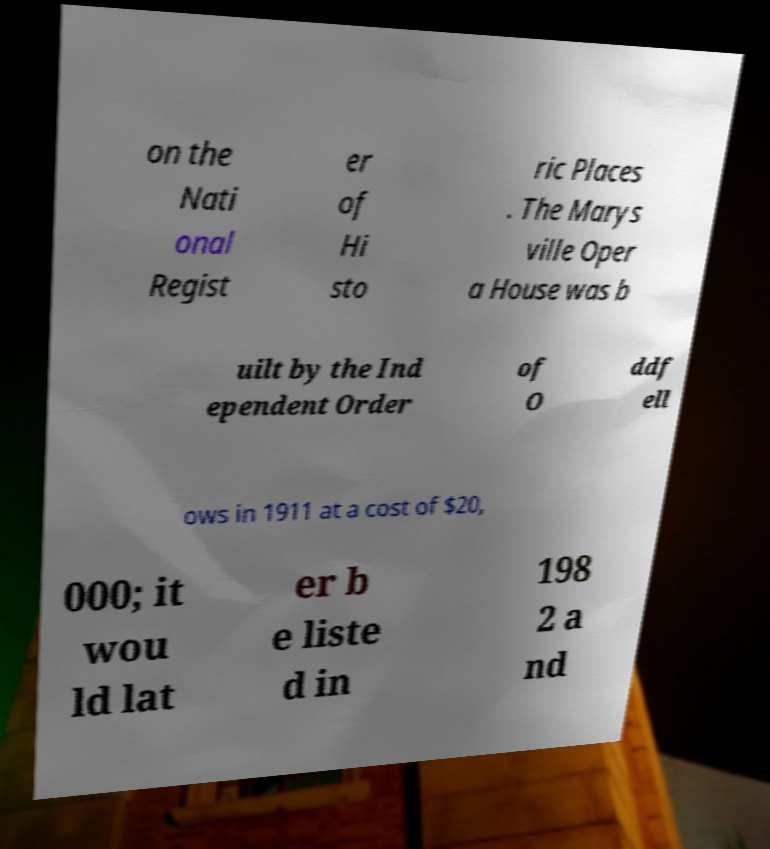Can you read and provide the text displayed in the image?This photo seems to have some interesting text. Can you extract and type it out for me? on the Nati onal Regist er of Hi sto ric Places . The Marys ville Oper a House was b uilt by the Ind ependent Order of O ddf ell ows in 1911 at a cost of $20, 000; it wou ld lat er b e liste d in 198 2 a nd 